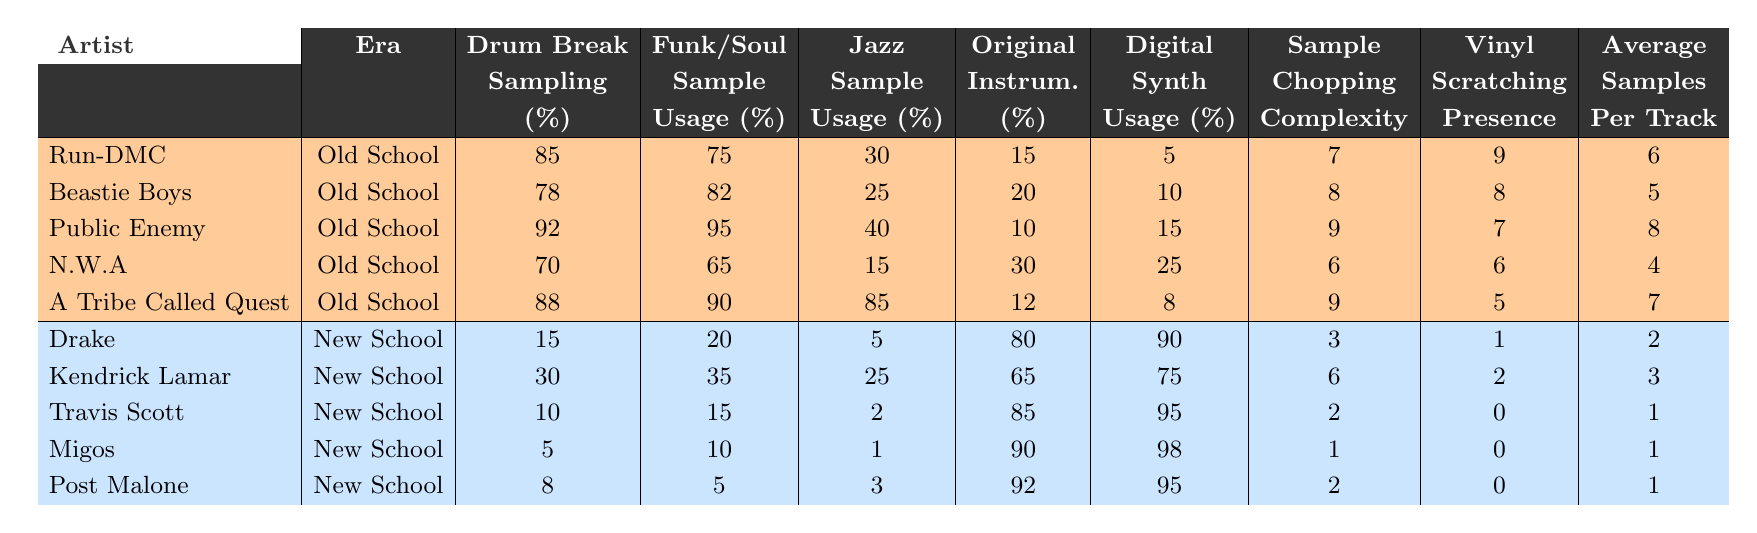What is the highest percentage of drum break sampling in old school hip-hop? Looking at the "Drum Break Sampling (%)" column for old school artists, Public Enemy has the highest value at 92%.
Answer: 92% Which new school artist has the least amount of jazz sample usage? In the "Jazz Sample Usage (%)" column for new school artists, Migos has the lowest usage at 1%.
Answer: 1% What is the average percentage of funk/soul sample usage in old school hip-hop? The funk/soul sample usage percentages for old school artists are 75, 82, 95, 65, and 90. Adding these gives 75 + 82 + 95 + 65 + 90 = 407, and dividing by 5 results in an average of 81.4%.
Answer: 81.4% Does any new school artist have a higher percentage of original instrumentation than any old school artist? Checking the "Original Instrumentation (%)" column, the highest for new school is Drake at 80%, while old school artists have percentages as high as 30%. Hence, no new school artist has a higher percentage.
Answer: No What is the difference in average samples per track between old school and new school artists? The average samples per track for old school artists is (6 + 5 + 8 + 4 + 7)/5 = 6.0 and for new school artists is (2 + 3 + 1 + 1 + 1)/5 = 1.6. The difference is 6.0 - 1.6 = 4.4.
Answer: 4.4 Which era has a higher average usage of digital synths? The digital synth usage for old school artists is (5 + 10 + 15 + 25 + 8)/5 = 13.6%, while for new school artists it is (90 + 75 + 95 + 98 + 95)/5 = 90.6%. Thus, new school has a higher average.
Answer: New School Is there a new school artist who uses more than 50% of funk/soul samples? Evaluating the "Funk/Soul Sample Usage (%)" column for new school artists, none of them exceed 50%—the maximum is 35% with Kendrick Lamar.
Answer: No How many more samples per track do old school artists average compared to Travis Scott? Old school artists average 6 samples per track and Travis Scott (a new school artist) averages 1 sample per track, so the difference is 6 - 1 = 5.
Answer: 5 Which artist has the highest vinyl scratching presence score and how does it compare to new school artists? The highest vinyl scratching score is 9 from Run-DMC. Comparing this to new school artists, who all have scores of 1 or 0, Run-DMC's score is significantly higher.
Answer: Run-DMC, significantly higher What is the total sampling complexity score for old school artists compared to new school? The total sampling complexity for old school artists is 7 + 8 + 9 + 6 + 9 = 39, while for new school it is 3 + 6 + 2 + 1 + 2 = 14. The difference is 39 - 14 = 25.
Answer: 25 Which era shows more reliance on drum break sampling based on the average percentage? For old school artists, the average drum break sampling is (85 + 78 + 92 + 70 + 88)/5 = 82.2%. For new school artists, it's (15 + 30 + 10 + 5 + 8)/5 = 13.6%. Old school shows more reliance.
Answer: Old School 